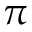Convert formula to latex. <formula><loc_0><loc_0><loc_500><loc_500>\pi</formula> 